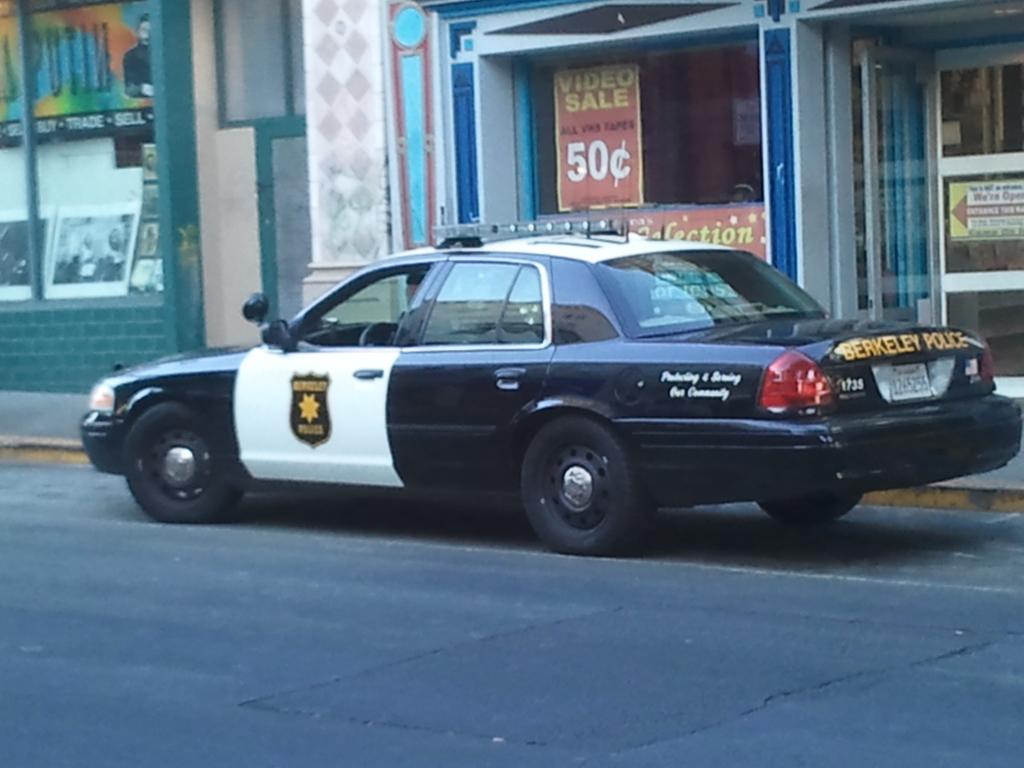What is on sale behind the police car?
Your response must be concise. Video. What city is this police car stationed in?
Make the answer very short. Berkeley. 